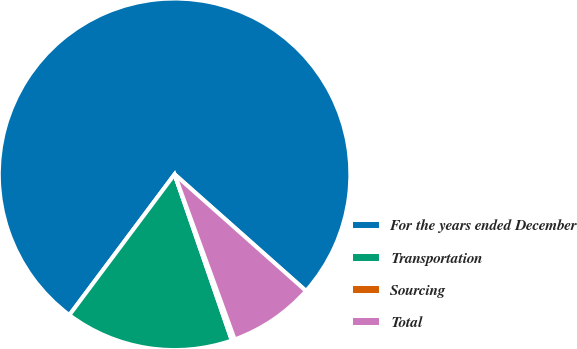Convert chart. <chart><loc_0><loc_0><loc_500><loc_500><pie_chart><fcel>For the years ended December<fcel>Transportation<fcel>Sourcing<fcel>Total<nl><fcel>76.33%<fcel>15.49%<fcel>0.28%<fcel>7.89%<nl></chart> 